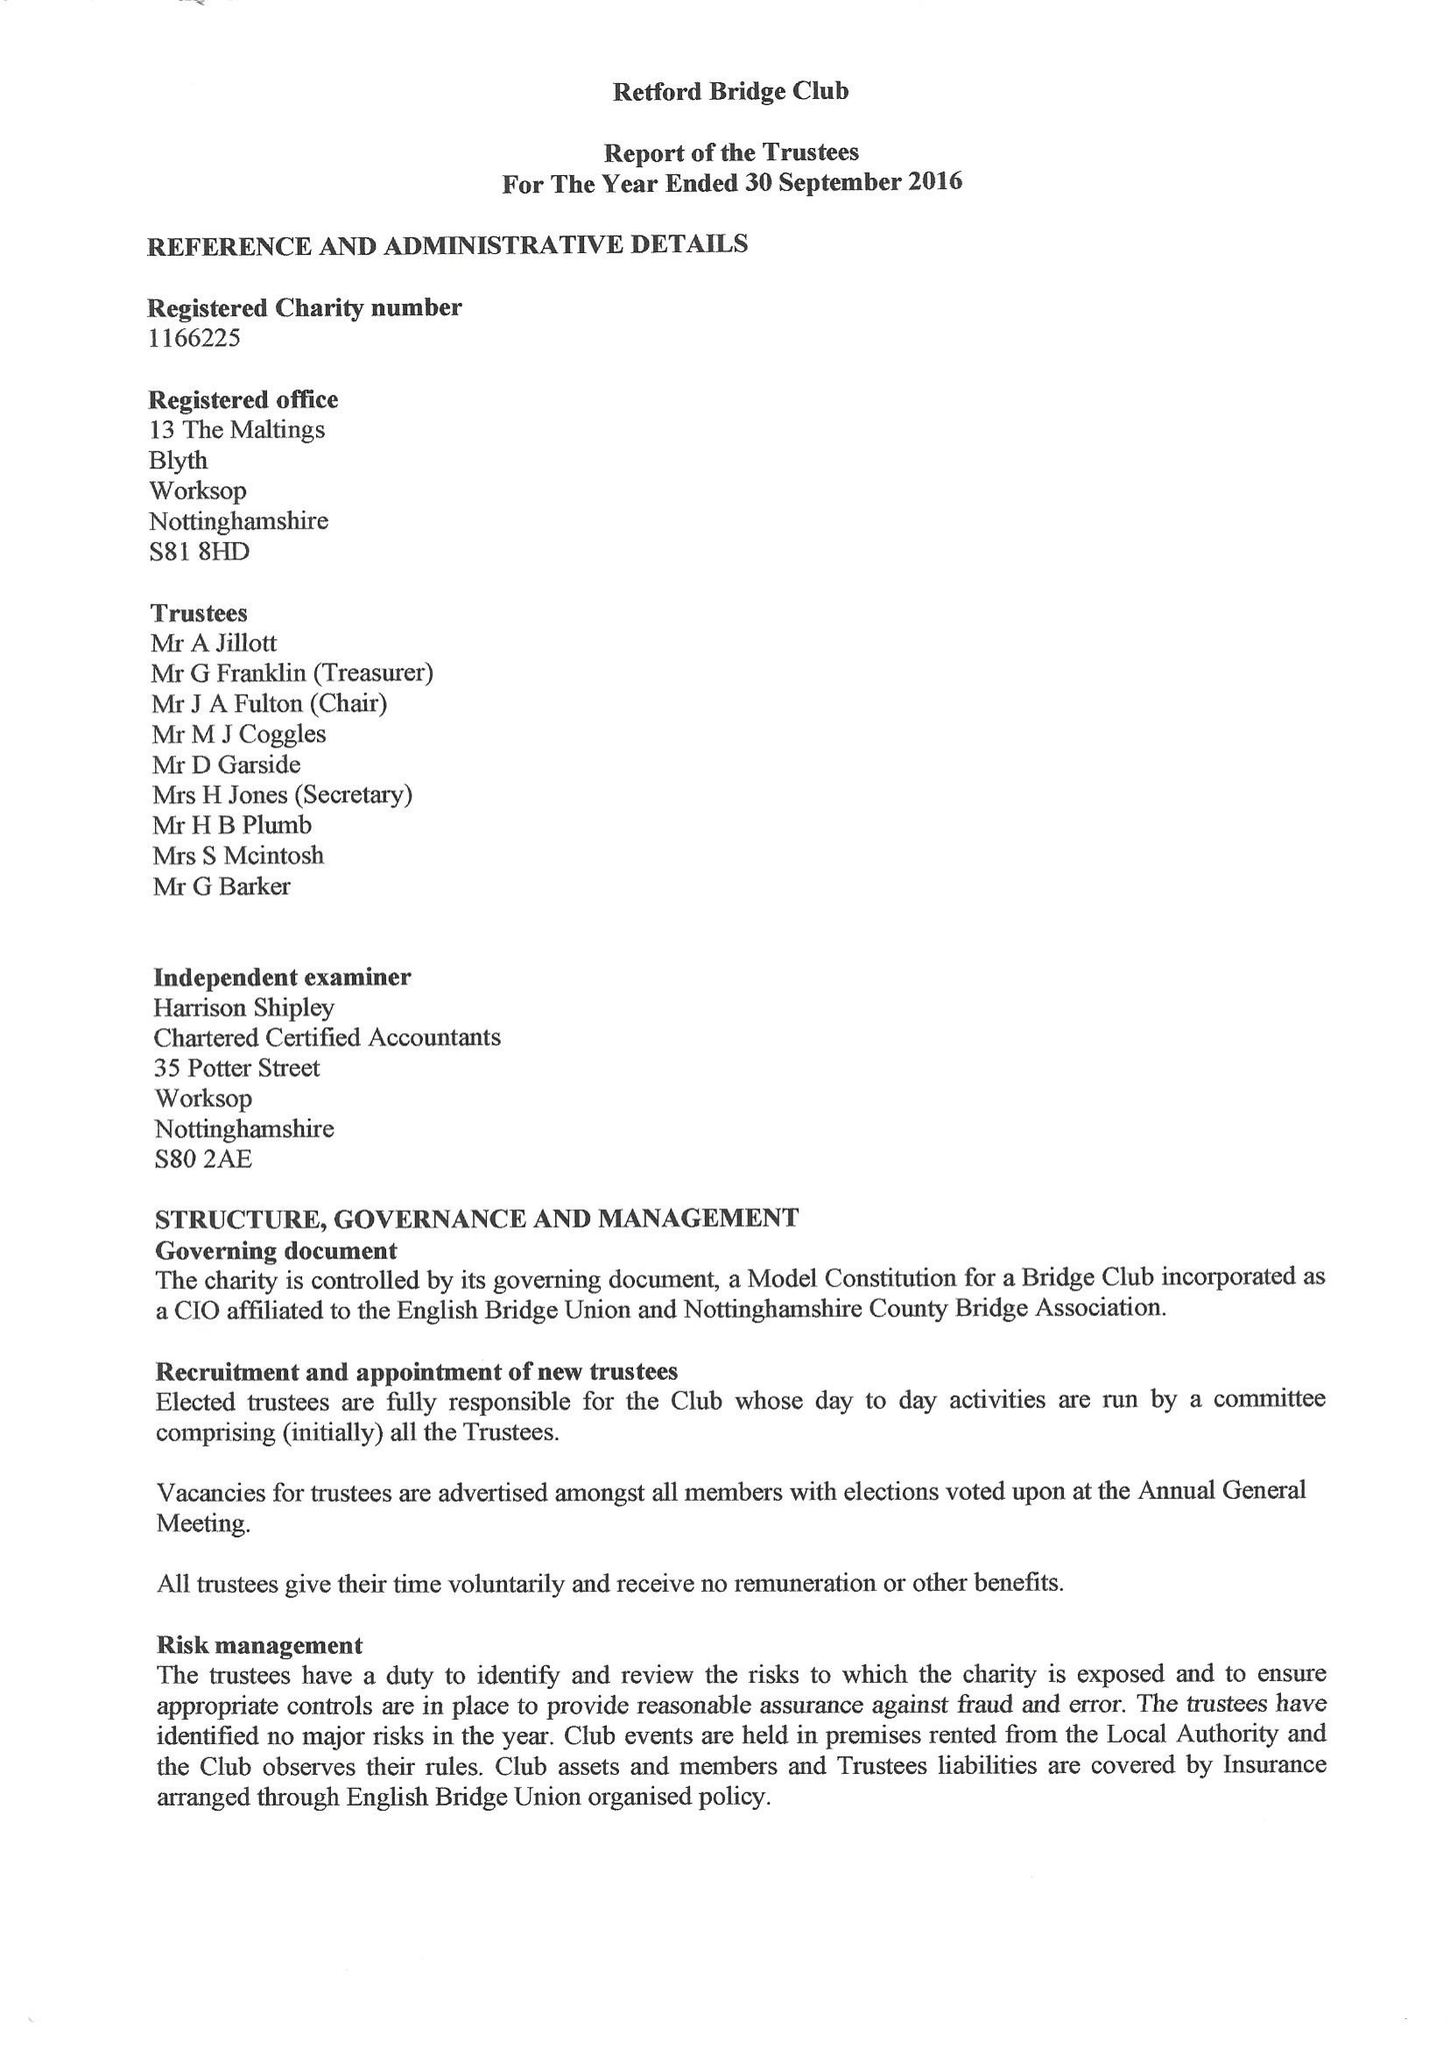What is the value for the charity_number?
Answer the question using a single word or phrase. 1166225 